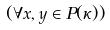Convert formula to latex. <formula><loc_0><loc_0><loc_500><loc_500>( \forall x , y \in P ( \kappa ) )</formula> 